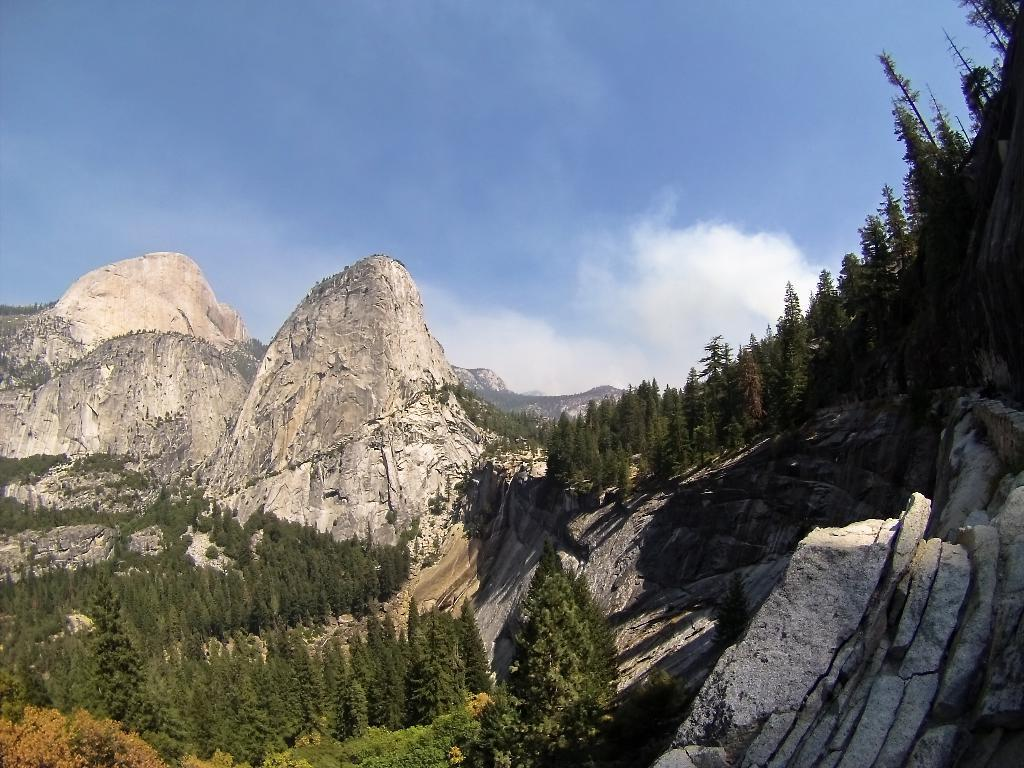What type of natural landscape can be seen in the background of the image? In the background of the image, there are mountains and trees. What else is visible in the background of the image? The sky is also visible in the background of the image. What suggestions were made by the committee in the image? There is no committee or suggestions present in the image; it features mountains, trees, and the sky. How does the slip affect the landscape in the image? There is no slip present in the image, so its effect on the landscape cannot be determined. 